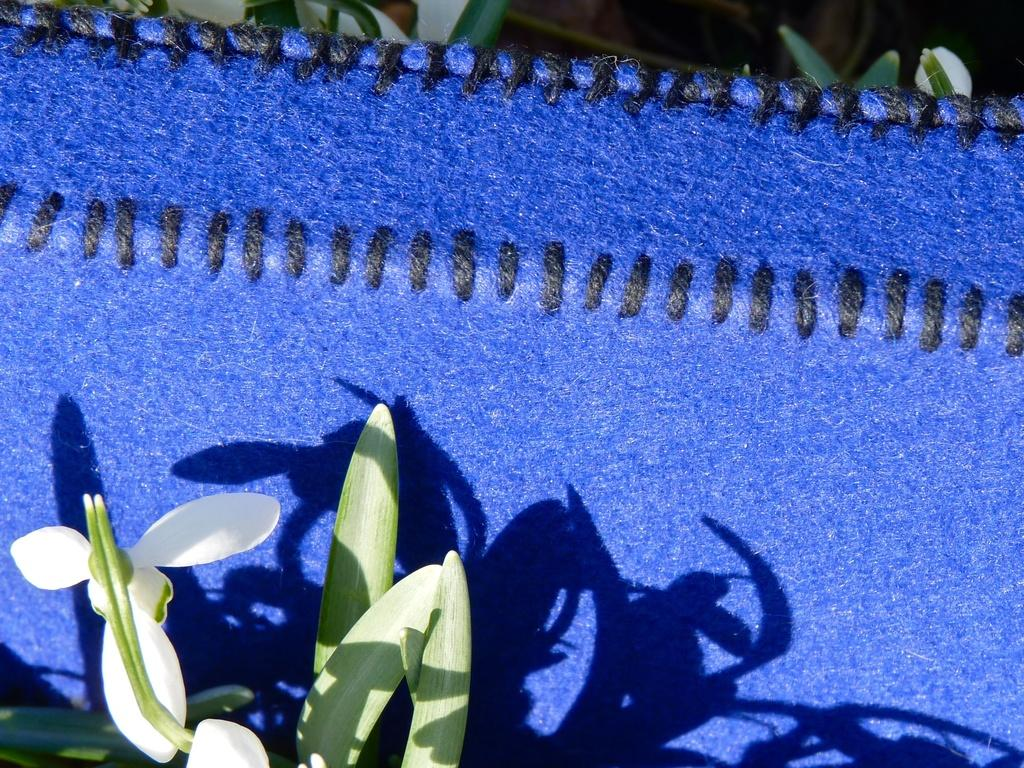What is located at the bottom of the image? There is a plant at the bottom of the image. What can be seen in the center of the image? There is a blue color cloth in the center of the image. Where is the oven located in the image? There is no oven present in the image. What type of hospital is depicted in the image? There is no hospital present in the image. 